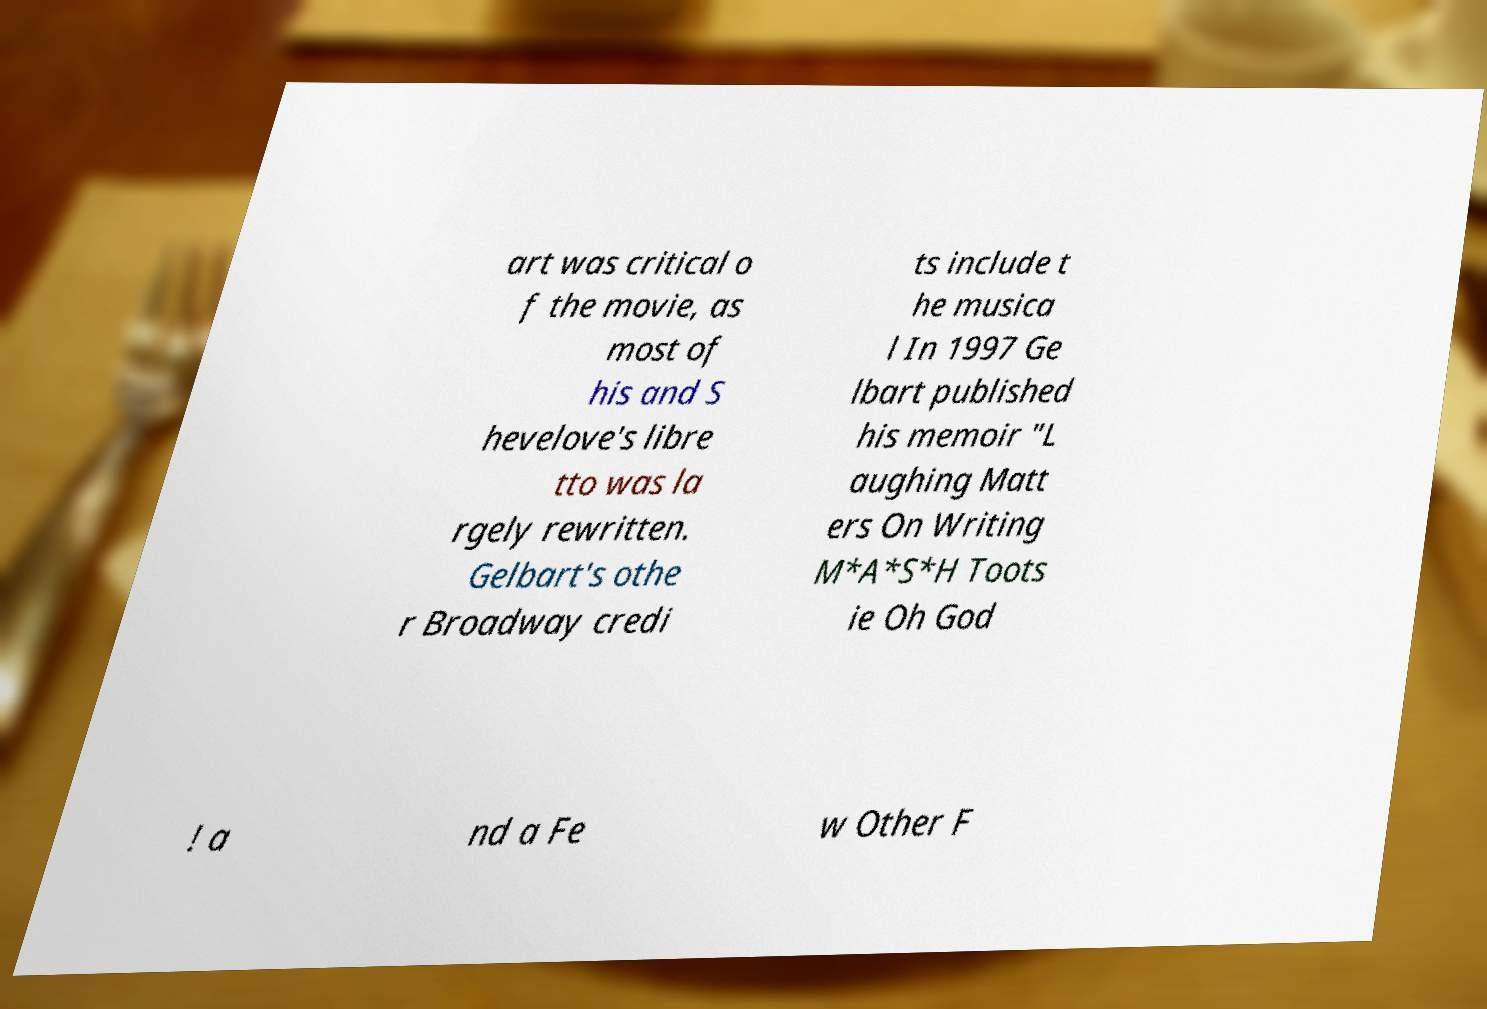Could you extract and type out the text from this image? art was critical o f the movie, as most of his and S hevelove's libre tto was la rgely rewritten. Gelbart's othe r Broadway credi ts include t he musica l In 1997 Ge lbart published his memoir "L aughing Matt ers On Writing M*A*S*H Toots ie Oh God ! a nd a Fe w Other F 